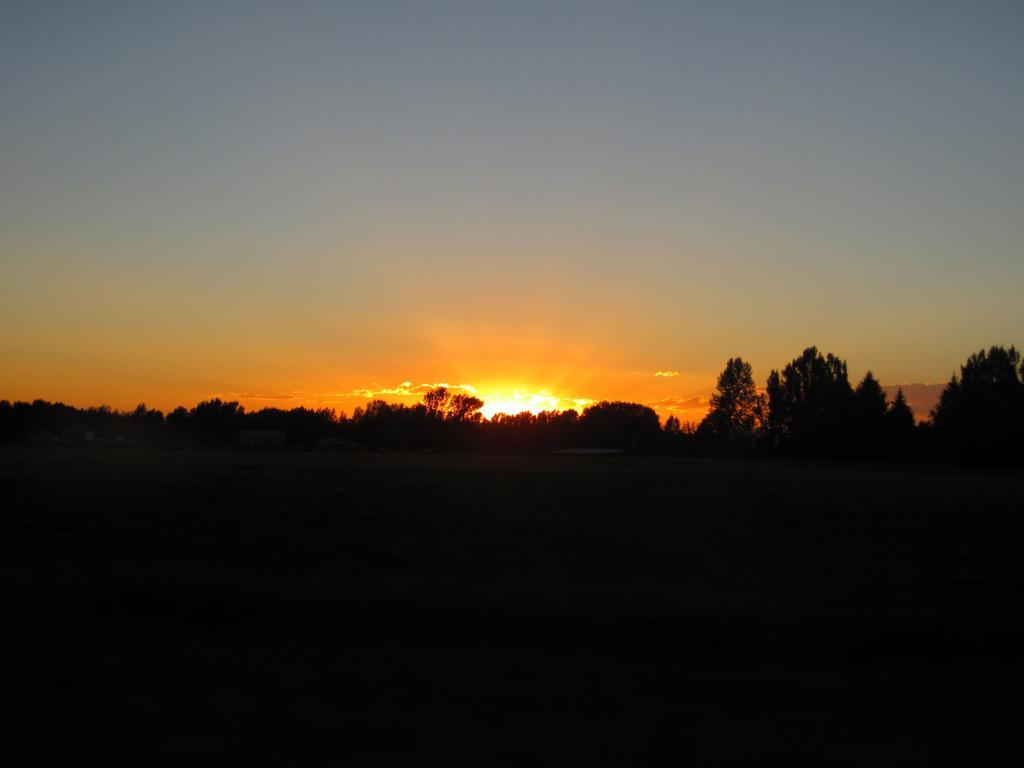How would you summarize this image in a sentence or two? In the image we can see trees and the sky. The bottom part of the image is dark. 